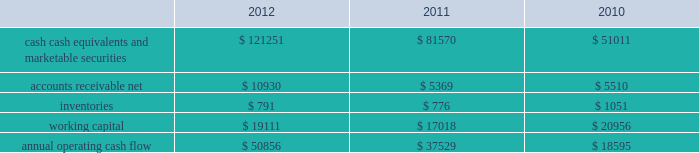35% ( 35 % ) due primarily to certain undistributed foreign earnings for which no u.s .
Taxes are provided because such earnings are intended to be indefinitely reinvested outside the u.s .
As of september 29 , 2012 , the company had deferred tax assets arising from deductible temporary differences , tax losses , and tax credits of $ 4.0 billion , and deferred tax liabilities of $ 14.9 billion .
Management believes it is more likely than not that forecasted income , including income that may be generated as a result of certain tax planning strategies , together with future reversals of existing taxable temporary differences , will be sufficient to fully recover the deferred tax assets .
The company will continue to evaluate the realizability of deferred tax assets quarterly by assessing the need for and amount of a valuation allowance .
The internal revenue service ( the 201cirs 201d ) has completed its field audit of the company 2019s federal income tax returns for the years 2004 through 2006 and proposed certain adjustments .
The company has contested certain of these adjustments through the irs appeals office .
The irs is currently examining the years 2007 through 2009 .
All irs audit issues for years prior to 2004 have been resolved .
In addition , the company is subject to audits by state , local , and foreign tax authorities .
Management believes that adequate provisions have been made for any adjustments that may result from tax examinations .
However , the outcome of tax audits cannot be predicted with certainty .
If any issues addressed in the company 2019s tax audits are resolved in a manner not consistent with management 2019s expectations , the company could be required to adjust its provision for income taxes in the period such resolution occurs .
Liquidity and capital resources the table presents selected financial information and statistics as of and for the years ended september 29 , 2012 , september 24 , 2011 , and september 25 , 2010 ( in millions ) : .
As of september 29 , 2012 , the company had $ 121.3 billion in cash , cash equivalents and marketable securities , an increase of $ 39.7 billion or 49% ( 49 % ) from september 24 , 2011 .
The principal components of this net increase was the cash generated by operating activities of $ 50.9 billion , which was partially offset by payments for acquisition of property , plant and equipment of $ 8.3 billion , payments for acquisition of intangible assets of $ 1.1 billion and payments of dividends and dividend equivalent rights of $ 2.5 billion .
The company 2019s marketable securities investment portfolio is invested primarily in highly-rated securities and its investment policy generally limits the amount of credit exposure to any one issuer .
The policy requires investments generally to be investment grade with the objective of minimizing the potential risk of principal loss .
As of september 29 , 2012 and september 24 , 2011 , $ 82.6 billion and $ 54.3 billion , respectively , of the company 2019s cash , cash equivalents and marketable securities were held by foreign subsidiaries and are generally based in u.s .
Dollar-denominated holdings .
Amounts held by foreign subsidiaries are generally subject to u.s .
Income taxation on repatriation to the u.s .
The company believes its existing balances of cash , cash equivalents and marketable securities will be sufficient to satisfy its working capital needs , capital asset purchases , outstanding commitments , common stock repurchases , dividends on its common stock , and other liquidity requirements associated with its existing operations over the next 12 months .
Capital assets the company 2019s capital expenditures were $ 10.3 billion during 2012 , consisting of $ 865 million for retail store facilities and $ 9.5 billion for other capital expenditures , including product tooling and manufacturing process .
What was the percentage change in the annual operating cash flow between 2010 and 2011? 
Computations: ((37529 - 18595) / 18595)
Answer: 1.01823. 